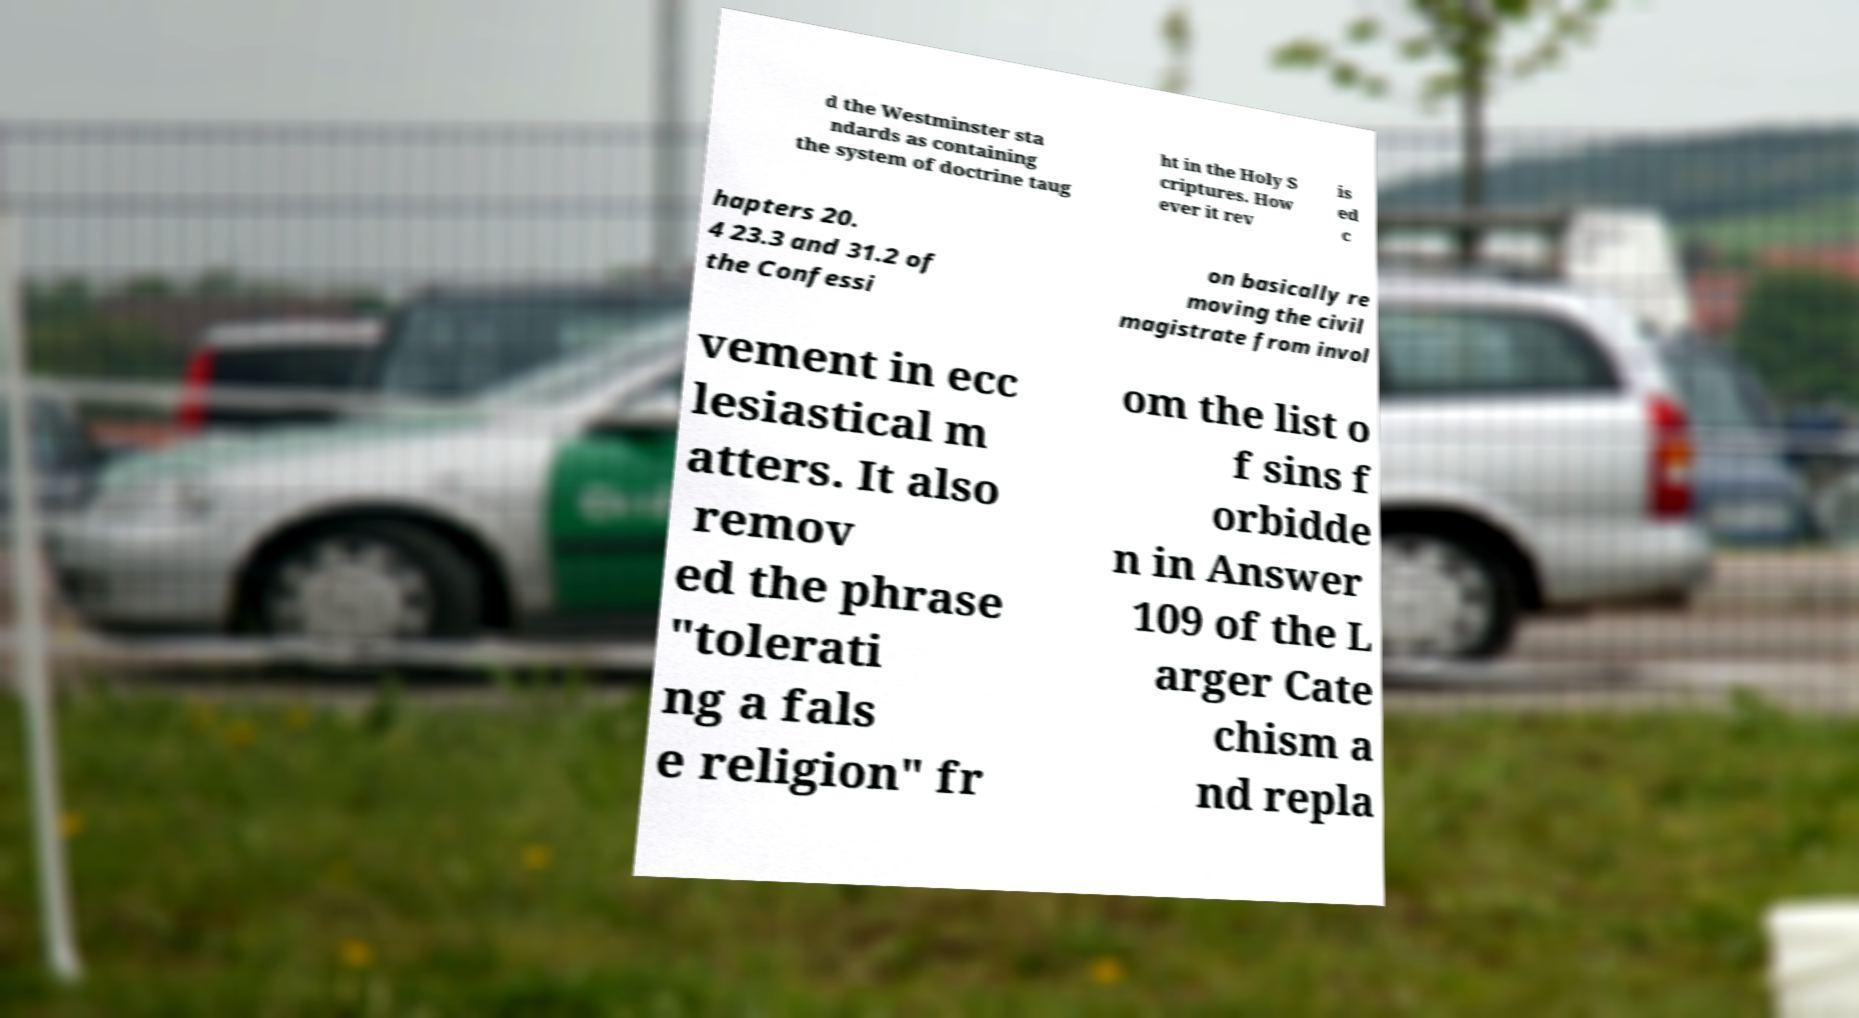Could you extract and type out the text from this image? d the Westminster sta ndards as containing the system of doctrine taug ht in the Holy S criptures. How ever it rev is ed c hapters 20. 4 23.3 and 31.2 of the Confessi on basically re moving the civil magistrate from invol vement in ecc lesiastical m atters. It also remov ed the phrase "tolerati ng a fals e religion" fr om the list o f sins f orbidde n in Answer 109 of the L arger Cate chism a nd repla 